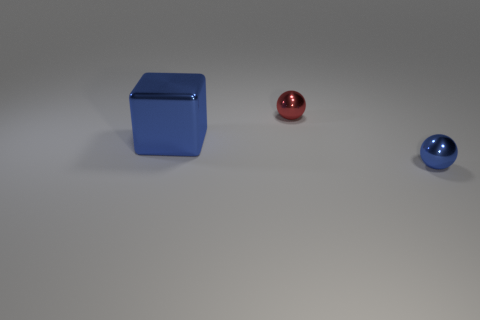Add 3 tiny red balls. How many objects exist? 6 Subtract all large green shiny cubes. Subtract all blue shiny spheres. How many objects are left? 2 Add 1 small shiny objects. How many small shiny objects are left? 3 Add 1 small red metal balls. How many small red metal balls exist? 2 Subtract 0 brown spheres. How many objects are left? 3 Subtract all cubes. How many objects are left? 2 